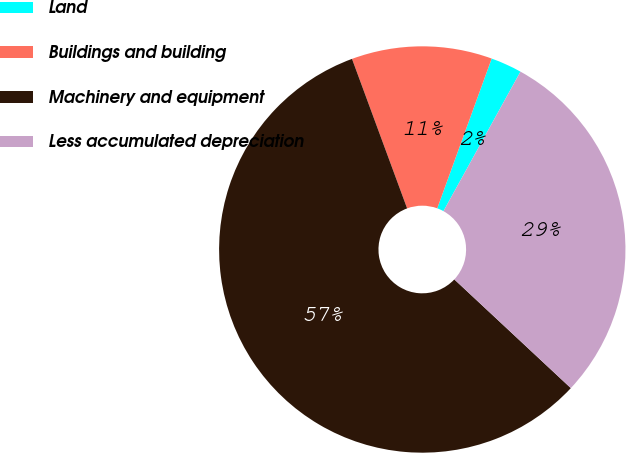Convert chart. <chart><loc_0><loc_0><loc_500><loc_500><pie_chart><fcel>Land<fcel>Buildings and building<fcel>Machinery and equipment<fcel>Less accumulated depreciation<nl><fcel>2.48%<fcel>11.17%<fcel>57.43%<fcel>28.92%<nl></chart> 